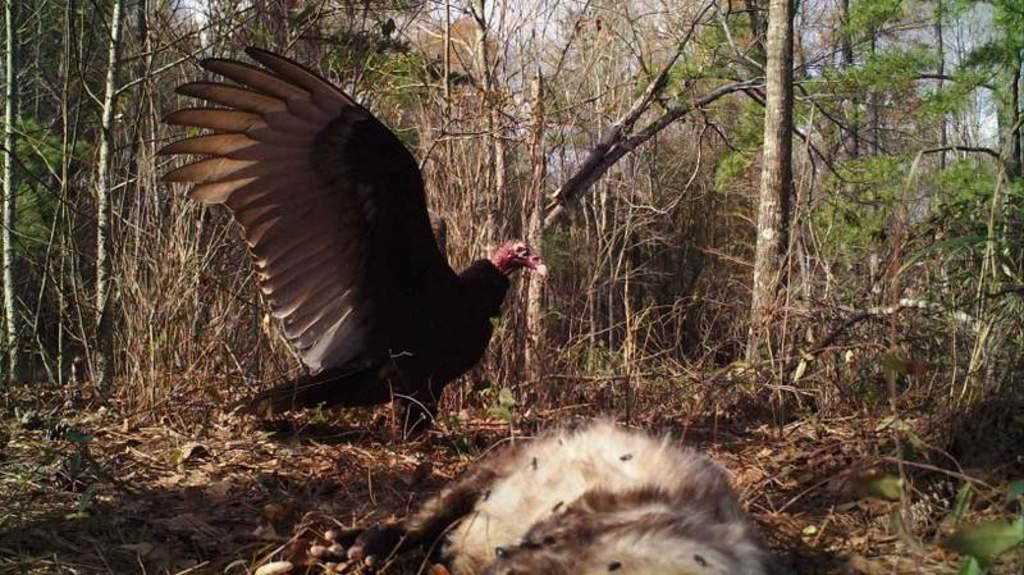What type of animal can be seen in the image? There is a bird in the image. What is the color of the bird? The bird is brown in color. What can be seen in the background of the image? There are trees and the sky visible in the background of the image. What is the color of the trees? The trees are green in color. What is the color of the sky in the image? The sky is white in color. How many sunflower seeds can be seen in the image? There are no sunflower seeds present in the image. What type of ticket is the bird holding in the image? There is no ticket present in the image; it features a bird and a background with trees and a white sky. 